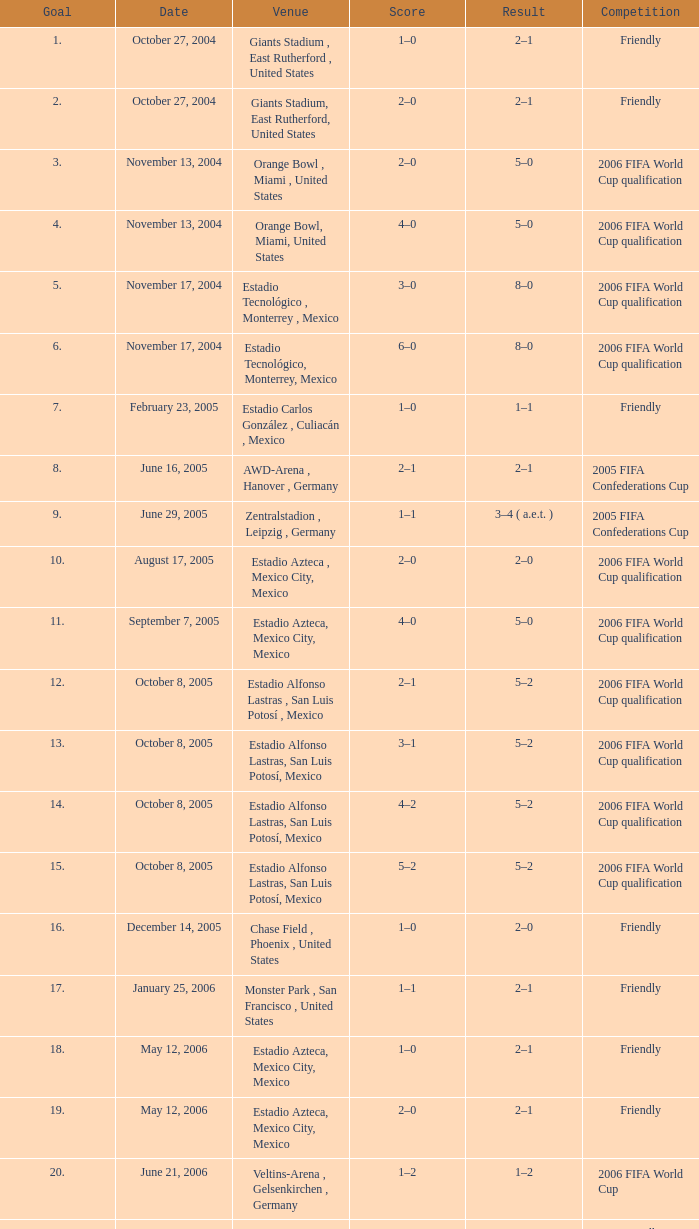Which Score has a Result of 2–1, and a Competition of friendly, and a Goal smaller than 17? 1–0, 2–0. 